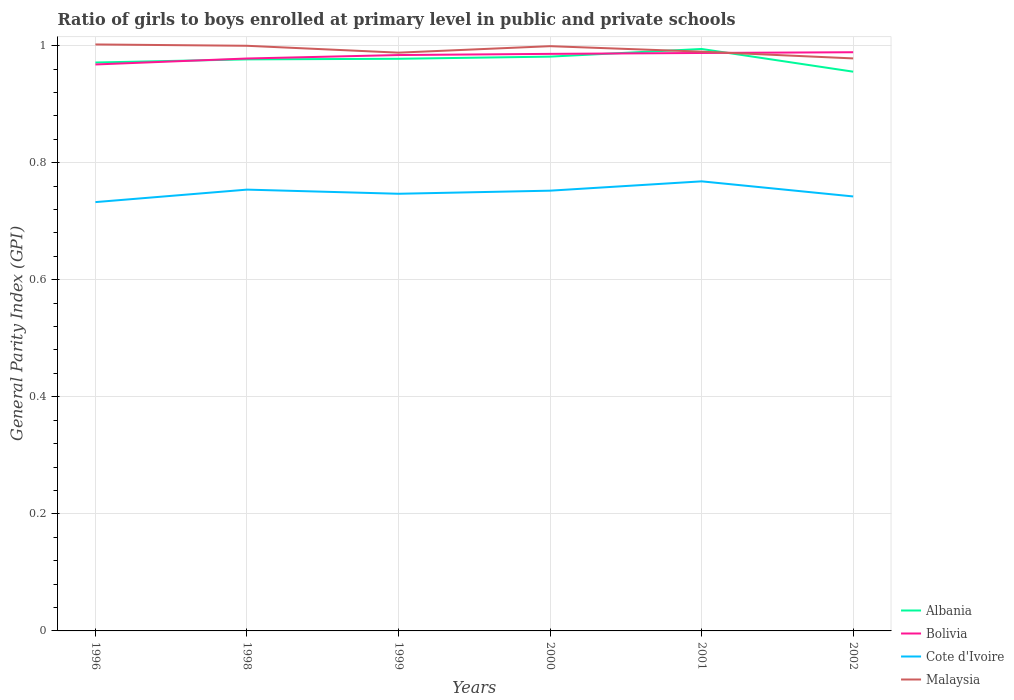How many different coloured lines are there?
Keep it short and to the point. 4. Does the line corresponding to Malaysia intersect with the line corresponding to Cote d'Ivoire?
Offer a terse response. No. Across all years, what is the maximum general parity index in Bolivia?
Offer a very short reply. 0.97. What is the total general parity index in Bolivia in the graph?
Your response must be concise. -0.02. What is the difference between the highest and the second highest general parity index in Malaysia?
Make the answer very short. 0.02. How many lines are there?
Your answer should be compact. 4. How many years are there in the graph?
Provide a short and direct response. 6. What is the title of the graph?
Offer a terse response. Ratio of girls to boys enrolled at primary level in public and private schools. What is the label or title of the Y-axis?
Your answer should be compact. General Parity Index (GPI). What is the General Parity Index (GPI) in Albania in 1996?
Your response must be concise. 0.97. What is the General Parity Index (GPI) in Bolivia in 1996?
Your answer should be very brief. 0.97. What is the General Parity Index (GPI) of Cote d'Ivoire in 1996?
Provide a succinct answer. 0.73. What is the General Parity Index (GPI) in Malaysia in 1996?
Offer a terse response. 1. What is the General Parity Index (GPI) of Albania in 1998?
Provide a succinct answer. 0.98. What is the General Parity Index (GPI) of Bolivia in 1998?
Your answer should be compact. 0.98. What is the General Parity Index (GPI) in Cote d'Ivoire in 1998?
Make the answer very short. 0.75. What is the General Parity Index (GPI) of Malaysia in 1998?
Offer a very short reply. 1. What is the General Parity Index (GPI) of Albania in 1999?
Provide a short and direct response. 0.98. What is the General Parity Index (GPI) of Bolivia in 1999?
Keep it short and to the point. 0.98. What is the General Parity Index (GPI) of Cote d'Ivoire in 1999?
Give a very brief answer. 0.75. What is the General Parity Index (GPI) in Malaysia in 1999?
Your answer should be compact. 0.99. What is the General Parity Index (GPI) of Albania in 2000?
Your answer should be compact. 0.98. What is the General Parity Index (GPI) of Bolivia in 2000?
Provide a succinct answer. 0.99. What is the General Parity Index (GPI) in Cote d'Ivoire in 2000?
Your answer should be very brief. 0.75. What is the General Parity Index (GPI) in Malaysia in 2000?
Your answer should be compact. 1. What is the General Parity Index (GPI) of Albania in 2001?
Ensure brevity in your answer.  0.99. What is the General Parity Index (GPI) in Bolivia in 2001?
Offer a very short reply. 0.99. What is the General Parity Index (GPI) in Cote d'Ivoire in 2001?
Ensure brevity in your answer.  0.77. What is the General Parity Index (GPI) of Malaysia in 2001?
Your answer should be compact. 0.99. What is the General Parity Index (GPI) in Albania in 2002?
Provide a succinct answer. 0.96. What is the General Parity Index (GPI) in Bolivia in 2002?
Provide a succinct answer. 0.99. What is the General Parity Index (GPI) of Cote d'Ivoire in 2002?
Keep it short and to the point. 0.74. What is the General Parity Index (GPI) in Malaysia in 2002?
Provide a short and direct response. 0.98. Across all years, what is the maximum General Parity Index (GPI) of Albania?
Give a very brief answer. 0.99. Across all years, what is the maximum General Parity Index (GPI) in Bolivia?
Offer a terse response. 0.99. Across all years, what is the maximum General Parity Index (GPI) in Cote d'Ivoire?
Make the answer very short. 0.77. Across all years, what is the maximum General Parity Index (GPI) of Malaysia?
Ensure brevity in your answer.  1. Across all years, what is the minimum General Parity Index (GPI) in Albania?
Your answer should be very brief. 0.96. Across all years, what is the minimum General Parity Index (GPI) in Bolivia?
Your answer should be very brief. 0.97. Across all years, what is the minimum General Parity Index (GPI) of Cote d'Ivoire?
Keep it short and to the point. 0.73. Across all years, what is the minimum General Parity Index (GPI) in Malaysia?
Provide a succinct answer. 0.98. What is the total General Parity Index (GPI) in Albania in the graph?
Your answer should be compact. 5.86. What is the total General Parity Index (GPI) of Bolivia in the graph?
Offer a terse response. 5.89. What is the total General Parity Index (GPI) in Cote d'Ivoire in the graph?
Ensure brevity in your answer.  4.5. What is the total General Parity Index (GPI) of Malaysia in the graph?
Provide a succinct answer. 5.96. What is the difference between the General Parity Index (GPI) in Albania in 1996 and that in 1998?
Offer a very short reply. -0.01. What is the difference between the General Parity Index (GPI) in Bolivia in 1996 and that in 1998?
Provide a succinct answer. -0.01. What is the difference between the General Parity Index (GPI) in Cote d'Ivoire in 1996 and that in 1998?
Provide a succinct answer. -0.02. What is the difference between the General Parity Index (GPI) in Malaysia in 1996 and that in 1998?
Offer a terse response. 0. What is the difference between the General Parity Index (GPI) in Albania in 1996 and that in 1999?
Offer a very short reply. -0.01. What is the difference between the General Parity Index (GPI) in Bolivia in 1996 and that in 1999?
Your answer should be compact. -0.02. What is the difference between the General Parity Index (GPI) in Cote d'Ivoire in 1996 and that in 1999?
Your answer should be very brief. -0.01. What is the difference between the General Parity Index (GPI) of Malaysia in 1996 and that in 1999?
Provide a succinct answer. 0.01. What is the difference between the General Parity Index (GPI) in Albania in 1996 and that in 2000?
Your response must be concise. -0.01. What is the difference between the General Parity Index (GPI) in Bolivia in 1996 and that in 2000?
Offer a terse response. -0.02. What is the difference between the General Parity Index (GPI) of Cote d'Ivoire in 1996 and that in 2000?
Your answer should be compact. -0.02. What is the difference between the General Parity Index (GPI) of Malaysia in 1996 and that in 2000?
Your answer should be very brief. 0. What is the difference between the General Parity Index (GPI) of Albania in 1996 and that in 2001?
Offer a very short reply. -0.02. What is the difference between the General Parity Index (GPI) of Bolivia in 1996 and that in 2001?
Keep it short and to the point. -0.02. What is the difference between the General Parity Index (GPI) in Cote d'Ivoire in 1996 and that in 2001?
Your response must be concise. -0.04. What is the difference between the General Parity Index (GPI) in Malaysia in 1996 and that in 2001?
Your answer should be compact. 0.01. What is the difference between the General Parity Index (GPI) in Albania in 1996 and that in 2002?
Your answer should be very brief. 0.02. What is the difference between the General Parity Index (GPI) of Bolivia in 1996 and that in 2002?
Your answer should be very brief. -0.02. What is the difference between the General Parity Index (GPI) of Cote d'Ivoire in 1996 and that in 2002?
Provide a short and direct response. -0.01. What is the difference between the General Parity Index (GPI) of Malaysia in 1996 and that in 2002?
Offer a terse response. 0.02. What is the difference between the General Parity Index (GPI) in Albania in 1998 and that in 1999?
Your answer should be compact. -0. What is the difference between the General Parity Index (GPI) of Bolivia in 1998 and that in 1999?
Ensure brevity in your answer.  -0.01. What is the difference between the General Parity Index (GPI) of Cote d'Ivoire in 1998 and that in 1999?
Offer a terse response. 0.01. What is the difference between the General Parity Index (GPI) of Malaysia in 1998 and that in 1999?
Your answer should be very brief. 0.01. What is the difference between the General Parity Index (GPI) of Albania in 1998 and that in 2000?
Make the answer very short. -0. What is the difference between the General Parity Index (GPI) of Bolivia in 1998 and that in 2000?
Give a very brief answer. -0.01. What is the difference between the General Parity Index (GPI) in Cote d'Ivoire in 1998 and that in 2000?
Provide a short and direct response. 0. What is the difference between the General Parity Index (GPI) of Malaysia in 1998 and that in 2000?
Provide a succinct answer. 0. What is the difference between the General Parity Index (GPI) in Albania in 1998 and that in 2001?
Your answer should be very brief. -0.02. What is the difference between the General Parity Index (GPI) in Bolivia in 1998 and that in 2001?
Give a very brief answer. -0.01. What is the difference between the General Parity Index (GPI) of Cote d'Ivoire in 1998 and that in 2001?
Give a very brief answer. -0.01. What is the difference between the General Parity Index (GPI) of Malaysia in 1998 and that in 2001?
Provide a short and direct response. 0.01. What is the difference between the General Parity Index (GPI) of Albania in 1998 and that in 2002?
Ensure brevity in your answer.  0.02. What is the difference between the General Parity Index (GPI) of Bolivia in 1998 and that in 2002?
Your response must be concise. -0.01. What is the difference between the General Parity Index (GPI) of Cote d'Ivoire in 1998 and that in 2002?
Provide a short and direct response. 0.01. What is the difference between the General Parity Index (GPI) of Malaysia in 1998 and that in 2002?
Your answer should be very brief. 0.02. What is the difference between the General Parity Index (GPI) in Albania in 1999 and that in 2000?
Ensure brevity in your answer.  -0. What is the difference between the General Parity Index (GPI) of Bolivia in 1999 and that in 2000?
Keep it short and to the point. -0. What is the difference between the General Parity Index (GPI) in Cote d'Ivoire in 1999 and that in 2000?
Make the answer very short. -0.01. What is the difference between the General Parity Index (GPI) of Malaysia in 1999 and that in 2000?
Keep it short and to the point. -0.01. What is the difference between the General Parity Index (GPI) in Albania in 1999 and that in 2001?
Give a very brief answer. -0.02. What is the difference between the General Parity Index (GPI) in Bolivia in 1999 and that in 2001?
Offer a terse response. -0. What is the difference between the General Parity Index (GPI) of Cote d'Ivoire in 1999 and that in 2001?
Make the answer very short. -0.02. What is the difference between the General Parity Index (GPI) of Malaysia in 1999 and that in 2001?
Your answer should be compact. -0. What is the difference between the General Parity Index (GPI) in Albania in 1999 and that in 2002?
Give a very brief answer. 0.02. What is the difference between the General Parity Index (GPI) in Bolivia in 1999 and that in 2002?
Offer a very short reply. -0. What is the difference between the General Parity Index (GPI) of Cote d'Ivoire in 1999 and that in 2002?
Provide a succinct answer. 0. What is the difference between the General Parity Index (GPI) of Malaysia in 1999 and that in 2002?
Keep it short and to the point. 0.01. What is the difference between the General Parity Index (GPI) in Albania in 2000 and that in 2001?
Ensure brevity in your answer.  -0.01. What is the difference between the General Parity Index (GPI) of Bolivia in 2000 and that in 2001?
Your response must be concise. -0. What is the difference between the General Parity Index (GPI) of Cote d'Ivoire in 2000 and that in 2001?
Ensure brevity in your answer.  -0.02. What is the difference between the General Parity Index (GPI) in Malaysia in 2000 and that in 2001?
Offer a very short reply. 0.01. What is the difference between the General Parity Index (GPI) in Albania in 2000 and that in 2002?
Make the answer very short. 0.03. What is the difference between the General Parity Index (GPI) of Bolivia in 2000 and that in 2002?
Your answer should be compact. -0. What is the difference between the General Parity Index (GPI) in Cote d'Ivoire in 2000 and that in 2002?
Your answer should be very brief. 0.01. What is the difference between the General Parity Index (GPI) in Malaysia in 2000 and that in 2002?
Provide a succinct answer. 0.02. What is the difference between the General Parity Index (GPI) in Albania in 2001 and that in 2002?
Give a very brief answer. 0.04. What is the difference between the General Parity Index (GPI) of Bolivia in 2001 and that in 2002?
Give a very brief answer. -0. What is the difference between the General Parity Index (GPI) of Cote d'Ivoire in 2001 and that in 2002?
Give a very brief answer. 0.03. What is the difference between the General Parity Index (GPI) in Malaysia in 2001 and that in 2002?
Offer a terse response. 0.01. What is the difference between the General Parity Index (GPI) of Albania in 1996 and the General Parity Index (GPI) of Bolivia in 1998?
Give a very brief answer. -0.01. What is the difference between the General Parity Index (GPI) of Albania in 1996 and the General Parity Index (GPI) of Cote d'Ivoire in 1998?
Make the answer very short. 0.22. What is the difference between the General Parity Index (GPI) in Albania in 1996 and the General Parity Index (GPI) in Malaysia in 1998?
Your response must be concise. -0.03. What is the difference between the General Parity Index (GPI) of Bolivia in 1996 and the General Parity Index (GPI) of Cote d'Ivoire in 1998?
Offer a terse response. 0.21. What is the difference between the General Parity Index (GPI) of Bolivia in 1996 and the General Parity Index (GPI) of Malaysia in 1998?
Offer a very short reply. -0.03. What is the difference between the General Parity Index (GPI) in Cote d'Ivoire in 1996 and the General Parity Index (GPI) in Malaysia in 1998?
Give a very brief answer. -0.27. What is the difference between the General Parity Index (GPI) of Albania in 1996 and the General Parity Index (GPI) of Bolivia in 1999?
Provide a short and direct response. -0.01. What is the difference between the General Parity Index (GPI) of Albania in 1996 and the General Parity Index (GPI) of Cote d'Ivoire in 1999?
Your response must be concise. 0.22. What is the difference between the General Parity Index (GPI) in Albania in 1996 and the General Parity Index (GPI) in Malaysia in 1999?
Make the answer very short. -0.02. What is the difference between the General Parity Index (GPI) in Bolivia in 1996 and the General Parity Index (GPI) in Cote d'Ivoire in 1999?
Offer a terse response. 0.22. What is the difference between the General Parity Index (GPI) in Bolivia in 1996 and the General Parity Index (GPI) in Malaysia in 1999?
Provide a short and direct response. -0.02. What is the difference between the General Parity Index (GPI) in Cote d'Ivoire in 1996 and the General Parity Index (GPI) in Malaysia in 1999?
Provide a short and direct response. -0.26. What is the difference between the General Parity Index (GPI) of Albania in 1996 and the General Parity Index (GPI) of Bolivia in 2000?
Your answer should be very brief. -0.01. What is the difference between the General Parity Index (GPI) in Albania in 1996 and the General Parity Index (GPI) in Cote d'Ivoire in 2000?
Give a very brief answer. 0.22. What is the difference between the General Parity Index (GPI) in Albania in 1996 and the General Parity Index (GPI) in Malaysia in 2000?
Give a very brief answer. -0.03. What is the difference between the General Parity Index (GPI) in Bolivia in 1996 and the General Parity Index (GPI) in Cote d'Ivoire in 2000?
Offer a terse response. 0.22. What is the difference between the General Parity Index (GPI) of Bolivia in 1996 and the General Parity Index (GPI) of Malaysia in 2000?
Give a very brief answer. -0.03. What is the difference between the General Parity Index (GPI) of Cote d'Ivoire in 1996 and the General Parity Index (GPI) of Malaysia in 2000?
Offer a very short reply. -0.27. What is the difference between the General Parity Index (GPI) of Albania in 1996 and the General Parity Index (GPI) of Bolivia in 2001?
Give a very brief answer. -0.02. What is the difference between the General Parity Index (GPI) of Albania in 1996 and the General Parity Index (GPI) of Cote d'Ivoire in 2001?
Your response must be concise. 0.2. What is the difference between the General Parity Index (GPI) of Albania in 1996 and the General Parity Index (GPI) of Malaysia in 2001?
Offer a terse response. -0.02. What is the difference between the General Parity Index (GPI) in Bolivia in 1996 and the General Parity Index (GPI) in Cote d'Ivoire in 2001?
Offer a very short reply. 0.2. What is the difference between the General Parity Index (GPI) in Bolivia in 1996 and the General Parity Index (GPI) in Malaysia in 2001?
Your response must be concise. -0.02. What is the difference between the General Parity Index (GPI) in Cote d'Ivoire in 1996 and the General Parity Index (GPI) in Malaysia in 2001?
Keep it short and to the point. -0.26. What is the difference between the General Parity Index (GPI) of Albania in 1996 and the General Parity Index (GPI) of Bolivia in 2002?
Make the answer very short. -0.02. What is the difference between the General Parity Index (GPI) of Albania in 1996 and the General Parity Index (GPI) of Cote d'Ivoire in 2002?
Your answer should be compact. 0.23. What is the difference between the General Parity Index (GPI) of Albania in 1996 and the General Parity Index (GPI) of Malaysia in 2002?
Provide a succinct answer. -0.01. What is the difference between the General Parity Index (GPI) in Bolivia in 1996 and the General Parity Index (GPI) in Cote d'Ivoire in 2002?
Make the answer very short. 0.23. What is the difference between the General Parity Index (GPI) of Bolivia in 1996 and the General Parity Index (GPI) of Malaysia in 2002?
Provide a short and direct response. -0.01. What is the difference between the General Parity Index (GPI) in Cote d'Ivoire in 1996 and the General Parity Index (GPI) in Malaysia in 2002?
Make the answer very short. -0.25. What is the difference between the General Parity Index (GPI) in Albania in 1998 and the General Parity Index (GPI) in Bolivia in 1999?
Provide a short and direct response. -0.01. What is the difference between the General Parity Index (GPI) in Albania in 1998 and the General Parity Index (GPI) in Cote d'Ivoire in 1999?
Give a very brief answer. 0.23. What is the difference between the General Parity Index (GPI) of Albania in 1998 and the General Parity Index (GPI) of Malaysia in 1999?
Give a very brief answer. -0.01. What is the difference between the General Parity Index (GPI) of Bolivia in 1998 and the General Parity Index (GPI) of Cote d'Ivoire in 1999?
Provide a short and direct response. 0.23. What is the difference between the General Parity Index (GPI) in Bolivia in 1998 and the General Parity Index (GPI) in Malaysia in 1999?
Your answer should be very brief. -0.01. What is the difference between the General Parity Index (GPI) in Cote d'Ivoire in 1998 and the General Parity Index (GPI) in Malaysia in 1999?
Offer a terse response. -0.23. What is the difference between the General Parity Index (GPI) of Albania in 1998 and the General Parity Index (GPI) of Bolivia in 2000?
Your response must be concise. -0.01. What is the difference between the General Parity Index (GPI) of Albania in 1998 and the General Parity Index (GPI) of Cote d'Ivoire in 2000?
Offer a terse response. 0.22. What is the difference between the General Parity Index (GPI) in Albania in 1998 and the General Parity Index (GPI) in Malaysia in 2000?
Give a very brief answer. -0.02. What is the difference between the General Parity Index (GPI) in Bolivia in 1998 and the General Parity Index (GPI) in Cote d'Ivoire in 2000?
Make the answer very short. 0.23. What is the difference between the General Parity Index (GPI) in Bolivia in 1998 and the General Parity Index (GPI) in Malaysia in 2000?
Ensure brevity in your answer.  -0.02. What is the difference between the General Parity Index (GPI) of Cote d'Ivoire in 1998 and the General Parity Index (GPI) of Malaysia in 2000?
Your answer should be compact. -0.25. What is the difference between the General Parity Index (GPI) in Albania in 1998 and the General Parity Index (GPI) in Bolivia in 2001?
Provide a short and direct response. -0.01. What is the difference between the General Parity Index (GPI) of Albania in 1998 and the General Parity Index (GPI) of Cote d'Ivoire in 2001?
Provide a succinct answer. 0.21. What is the difference between the General Parity Index (GPI) of Albania in 1998 and the General Parity Index (GPI) of Malaysia in 2001?
Offer a very short reply. -0.01. What is the difference between the General Parity Index (GPI) in Bolivia in 1998 and the General Parity Index (GPI) in Cote d'Ivoire in 2001?
Offer a very short reply. 0.21. What is the difference between the General Parity Index (GPI) of Bolivia in 1998 and the General Parity Index (GPI) of Malaysia in 2001?
Offer a very short reply. -0.01. What is the difference between the General Parity Index (GPI) in Cote d'Ivoire in 1998 and the General Parity Index (GPI) in Malaysia in 2001?
Your answer should be compact. -0.24. What is the difference between the General Parity Index (GPI) of Albania in 1998 and the General Parity Index (GPI) of Bolivia in 2002?
Provide a short and direct response. -0.01. What is the difference between the General Parity Index (GPI) in Albania in 1998 and the General Parity Index (GPI) in Cote d'Ivoire in 2002?
Make the answer very short. 0.23. What is the difference between the General Parity Index (GPI) of Albania in 1998 and the General Parity Index (GPI) of Malaysia in 2002?
Your response must be concise. -0. What is the difference between the General Parity Index (GPI) of Bolivia in 1998 and the General Parity Index (GPI) of Cote d'Ivoire in 2002?
Provide a succinct answer. 0.24. What is the difference between the General Parity Index (GPI) of Bolivia in 1998 and the General Parity Index (GPI) of Malaysia in 2002?
Your answer should be compact. -0. What is the difference between the General Parity Index (GPI) in Cote d'Ivoire in 1998 and the General Parity Index (GPI) in Malaysia in 2002?
Give a very brief answer. -0.22. What is the difference between the General Parity Index (GPI) in Albania in 1999 and the General Parity Index (GPI) in Bolivia in 2000?
Provide a succinct answer. -0.01. What is the difference between the General Parity Index (GPI) of Albania in 1999 and the General Parity Index (GPI) of Cote d'Ivoire in 2000?
Ensure brevity in your answer.  0.23. What is the difference between the General Parity Index (GPI) of Albania in 1999 and the General Parity Index (GPI) of Malaysia in 2000?
Provide a short and direct response. -0.02. What is the difference between the General Parity Index (GPI) in Bolivia in 1999 and the General Parity Index (GPI) in Cote d'Ivoire in 2000?
Make the answer very short. 0.23. What is the difference between the General Parity Index (GPI) of Bolivia in 1999 and the General Parity Index (GPI) of Malaysia in 2000?
Your response must be concise. -0.02. What is the difference between the General Parity Index (GPI) in Cote d'Ivoire in 1999 and the General Parity Index (GPI) in Malaysia in 2000?
Give a very brief answer. -0.25. What is the difference between the General Parity Index (GPI) of Albania in 1999 and the General Parity Index (GPI) of Bolivia in 2001?
Offer a very short reply. -0.01. What is the difference between the General Parity Index (GPI) in Albania in 1999 and the General Parity Index (GPI) in Cote d'Ivoire in 2001?
Give a very brief answer. 0.21. What is the difference between the General Parity Index (GPI) in Albania in 1999 and the General Parity Index (GPI) in Malaysia in 2001?
Your answer should be compact. -0.01. What is the difference between the General Parity Index (GPI) in Bolivia in 1999 and the General Parity Index (GPI) in Cote d'Ivoire in 2001?
Offer a very short reply. 0.22. What is the difference between the General Parity Index (GPI) of Bolivia in 1999 and the General Parity Index (GPI) of Malaysia in 2001?
Your answer should be very brief. -0.01. What is the difference between the General Parity Index (GPI) in Cote d'Ivoire in 1999 and the General Parity Index (GPI) in Malaysia in 2001?
Offer a terse response. -0.24. What is the difference between the General Parity Index (GPI) of Albania in 1999 and the General Parity Index (GPI) of Bolivia in 2002?
Offer a terse response. -0.01. What is the difference between the General Parity Index (GPI) of Albania in 1999 and the General Parity Index (GPI) of Cote d'Ivoire in 2002?
Keep it short and to the point. 0.24. What is the difference between the General Parity Index (GPI) in Albania in 1999 and the General Parity Index (GPI) in Malaysia in 2002?
Your answer should be compact. -0. What is the difference between the General Parity Index (GPI) of Bolivia in 1999 and the General Parity Index (GPI) of Cote d'Ivoire in 2002?
Keep it short and to the point. 0.24. What is the difference between the General Parity Index (GPI) in Bolivia in 1999 and the General Parity Index (GPI) in Malaysia in 2002?
Give a very brief answer. 0.01. What is the difference between the General Parity Index (GPI) of Cote d'Ivoire in 1999 and the General Parity Index (GPI) of Malaysia in 2002?
Keep it short and to the point. -0.23. What is the difference between the General Parity Index (GPI) of Albania in 2000 and the General Parity Index (GPI) of Bolivia in 2001?
Make the answer very short. -0.01. What is the difference between the General Parity Index (GPI) of Albania in 2000 and the General Parity Index (GPI) of Cote d'Ivoire in 2001?
Offer a terse response. 0.21. What is the difference between the General Parity Index (GPI) in Albania in 2000 and the General Parity Index (GPI) in Malaysia in 2001?
Keep it short and to the point. -0.01. What is the difference between the General Parity Index (GPI) of Bolivia in 2000 and the General Parity Index (GPI) of Cote d'Ivoire in 2001?
Make the answer very short. 0.22. What is the difference between the General Parity Index (GPI) in Bolivia in 2000 and the General Parity Index (GPI) in Malaysia in 2001?
Offer a very short reply. -0. What is the difference between the General Parity Index (GPI) in Cote d'Ivoire in 2000 and the General Parity Index (GPI) in Malaysia in 2001?
Offer a very short reply. -0.24. What is the difference between the General Parity Index (GPI) in Albania in 2000 and the General Parity Index (GPI) in Bolivia in 2002?
Make the answer very short. -0.01. What is the difference between the General Parity Index (GPI) of Albania in 2000 and the General Parity Index (GPI) of Cote d'Ivoire in 2002?
Your answer should be very brief. 0.24. What is the difference between the General Parity Index (GPI) in Albania in 2000 and the General Parity Index (GPI) in Malaysia in 2002?
Keep it short and to the point. 0. What is the difference between the General Parity Index (GPI) in Bolivia in 2000 and the General Parity Index (GPI) in Cote d'Ivoire in 2002?
Offer a very short reply. 0.24. What is the difference between the General Parity Index (GPI) in Bolivia in 2000 and the General Parity Index (GPI) in Malaysia in 2002?
Your answer should be very brief. 0.01. What is the difference between the General Parity Index (GPI) of Cote d'Ivoire in 2000 and the General Parity Index (GPI) of Malaysia in 2002?
Keep it short and to the point. -0.23. What is the difference between the General Parity Index (GPI) of Albania in 2001 and the General Parity Index (GPI) of Bolivia in 2002?
Your answer should be compact. 0.01. What is the difference between the General Parity Index (GPI) in Albania in 2001 and the General Parity Index (GPI) in Cote d'Ivoire in 2002?
Make the answer very short. 0.25. What is the difference between the General Parity Index (GPI) of Albania in 2001 and the General Parity Index (GPI) of Malaysia in 2002?
Ensure brevity in your answer.  0.02. What is the difference between the General Parity Index (GPI) of Bolivia in 2001 and the General Parity Index (GPI) of Cote d'Ivoire in 2002?
Your response must be concise. 0.25. What is the difference between the General Parity Index (GPI) of Bolivia in 2001 and the General Parity Index (GPI) of Malaysia in 2002?
Your answer should be compact. 0.01. What is the difference between the General Parity Index (GPI) of Cote d'Ivoire in 2001 and the General Parity Index (GPI) of Malaysia in 2002?
Provide a short and direct response. -0.21. What is the average General Parity Index (GPI) of Albania per year?
Ensure brevity in your answer.  0.98. What is the average General Parity Index (GPI) of Cote d'Ivoire per year?
Offer a terse response. 0.75. In the year 1996, what is the difference between the General Parity Index (GPI) in Albania and General Parity Index (GPI) in Bolivia?
Make the answer very short. 0. In the year 1996, what is the difference between the General Parity Index (GPI) of Albania and General Parity Index (GPI) of Cote d'Ivoire?
Offer a terse response. 0.24. In the year 1996, what is the difference between the General Parity Index (GPI) of Albania and General Parity Index (GPI) of Malaysia?
Provide a succinct answer. -0.03. In the year 1996, what is the difference between the General Parity Index (GPI) of Bolivia and General Parity Index (GPI) of Cote d'Ivoire?
Your response must be concise. 0.24. In the year 1996, what is the difference between the General Parity Index (GPI) in Bolivia and General Parity Index (GPI) in Malaysia?
Provide a short and direct response. -0.03. In the year 1996, what is the difference between the General Parity Index (GPI) in Cote d'Ivoire and General Parity Index (GPI) in Malaysia?
Keep it short and to the point. -0.27. In the year 1998, what is the difference between the General Parity Index (GPI) of Albania and General Parity Index (GPI) of Bolivia?
Your answer should be very brief. -0. In the year 1998, what is the difference between the General Parity Index (GPI) in Albania and General Parity Index (GPI) in Cote d'Ivoire?
Your response must be concise. 0.22. In the year 1998, what is the difference between the General Parity Index (GPI) of Albania and General Parity Index (GPI) of Malaysia?
Ensure brevity in your answer.  -0.02. In the year 1998, what is the difference between the General Parity Index (GPI) of Bolivia and General Parity Index (GPI) of Cote d'Ivoire?
Make the answer very short. 0.22. In the year 1998, what is the difference between the General Parity Index (GPI) of Bolivia and General Parity Index (GPI) of Malaysia?
Make the answer very short. -0.02. In the year 1998, what is the difference between the General Parity Index (GPI) of Cote d'Ivoire and General Parity Index (GPI) of Malaysia?
Provide a succinct answer. -0.25. In the year 1999, what is the difference between the General Parity Index (GPI) in Albania and General Parity Index (GPI) in Bolivia?
Give a very brief answer. -0.01. In the year 1999, what is the difference between the General Parity Index (GPI) in Albania and General Parity Index (GPI) in Cote d'Ivoire?
Ensure brevity in your answer.  0.23. In the year 1999, what is the difference between the General Parity Index (GPI) of Albania and General Parity Index (GPI) of Malaysia?
Your answer should be compact. -0.01. In the year 1999, what is the difference between the General Parity Index (GPI) in Bolivia and General Parity Index (GPI) in Cote d'Ivoire?
Your response must be concise. 0.24. In the year 1999, what is the difference between the General Parity Index (GPI) of Bolivia and General Parity Index (GPI) of Malaysia?
Give a very brief answer. -0. In the year 1999, what is the difference between the General Parity Index (GPI) of Cote d'Ivoire and General Parity Index (GPI) of Malaysia?
Your response must be concise. -0.24. In the year 2000, what is the difference between the General Parity Index (GPI) of Albania and General Parity Index (GPI) of Bolivia?
Your answer should be compact. -0. In the year 2000, what is the difference between the General Parity Index (GPI) of Albania and General Parity Index (GPI) of Cote d'Ivoire?
Make the answer very short. 0.23. In the year 2000, what is the difference between the General Parity Index (GPI) of Albania and General Parity Index (GPI) of Malaysia?
Provide a succinct answer. -0.02. In the year 2000, what is the difference between the General Parity Index (GPI) of Bolivia and General Parity Index (GPI) of Cote d'Ivoire?
Your response must be concise. 0.23. In the year 2000, what is the difference between the General Parity Index (GPI) of Bolivia and General Parity Index (GPI) of Malaysia?
Make the answer very short. -0.01. In the year 2000, what is the difference between the General Parity Index (GPI) in Cote d'Ivoire and General Parity Index (GPI) in Malaysia?
Offer a very short reply. -0.25. In the year 2001, what is the difference between the General Parity Index (GPI) of Albania and General Parity Index (GPI) of Bolivia?
Give a very brief answer. 0.01. In the year 2001, what is the difference between the General Parity Index (GPI) in Albania and General Parity Index (GPI) in Cote d'Ivoire?
Offer a terse response. 0.23. In the year 2001, what is the difference between the General Parity Index (GPI) of Albania and General Parity Index (GPI) of Malaysia?
Ensure brevity in your answer.  0. In the year 2001, what is the difference between the General Parity Index (GPI) of Bolivia and General Parity Index (GPI) of Cote d'Ivoire?
Make the answer very short. 0.22. In the year 2001, what is the difference between the General Parity Index (GPI) of Bolivia and General Parity Index (GPI) of Malaysia?
Give a very brief answer. -0. In the year 2001, what is the difference between the General Parity Index (GPI) in Cote d'Ivoire and General Parity Index (GPI) in Malaysia?
Your answer should be very brief. -0.22. In the year 2002, what is the difference between the General Parity Index (GPI) in Albania and General Parity Index (GPI) in Bolivia?
Keep it short and to the point. -0.03. In the year 2002, what is the difference between the General Parity Index (GPI) of Albania and General Parity Index (GPI) of Cote d'Ivoire?
Your answer should be very brief. 0.21. In the year 2002, what is the difference between the General Parity Index (GPI) in Albania and General Parity Index (GPI) in Malaysia?
Offer a very short reply. -0.02. In the year 2002, what is the difference between the General Parity Index (GPI) of Bolivia and General Parity Index (GPI) of Cote d'Ivoire?
Your answer should be compact. 0.25. In the year 2002, what is the difference between the General Parity Index (GPI) in Bolivia and General Parity Index (GPI) in Malaysia?
Provide a succinct answer. 0.01. In the year 2002, what is the difference between the General Parity Index (GPI) of Cote d'Ivoire and General Parity Index (GPI) of Malaysia?
Offer a very short reply. -0.24. What is the ratio of the General Parity Index (GPI) in Bolivia in 1996 to that in 1998?
Give a very brief answer. 0.99. What is the ratio of the General Parity Index (GPI) of Cote d'Ivoire in 1996 to that in 1998?
Your answer should be very brief. 0.97. What is the ratio of the General Parity Index (GPI) of Albania in 1996 to that in 1999?
Keep it short and to the point. 0.99. What is the ratio of the General Parity Index (GPI) in Bolivia in 1996 to that in 1999?
Make the answer very short. 0.98. What is the ratio of the General Parity Index (GPI) of Cote d'Ivoire in 1996 to that in 1999?
Offer a very short reply. 0.98. What is the ratio of the General Parity Index (GPI) of Malaysia in 1996 to that in 1999?
Your answer should be compact. 1.01. What is the ratio of the General Parity Index (GPI) in Bolivia in 1996 to that in 2000?
Keep it short and to the point. 0.98. What is the ratio of the General Parity Index (GPI) in Albania in 1996 to that in 2001?
Provide a succinct answer. 0.98. What is the ratio of the General Parity Index (GPI) in Bolivia in 1996 to that in 2001?
Keep it short and to the point. 0.98. What is the ratio of the General Parity Index (GPI) of Cote d'Ivoire in 1996 to that in 2001?
Offer a very short reply. 0.95. What is the ratio of the General Parity Index (GPI) of Malaysia in 1996 to that in 2001?
Ensure brevity in your answer.  1.01. What is the ratio of the General Parity Index (GPI) in Albania in 1996 to that in 2002?
Offer a very short reply. 1.02. What is the ratio of the General Parity Index (GPI) of Bolivia in 1996 to that in 2002?
Make the answer very short. 0.98. What is the ratio of the General Parity Index (GPI) of Malaysia in 1996 to that in 2002?
Give a very brief answer. 1.02. What is the ratio of the General Parity Index (GPI) of Albania in 1998 to that in 1999?
Keep it short and to the point. 1. What is the ratio of the General Parity Index (GPI) in Cote d'Ivoire in 1998 to that in 1999?
Make the answer very short. 1.01. What is the ratio of the General Parity Index (GPI) in Malaysia in 1998 to that in 1999?
Ensure brevity in your answer.  1.01. What is the ratio of the General Parity Index (GPI) in Albania in 1998 to that in 2001?
Ensure brevity in your answer.  0.98. What is the ratio of the General Parity Index (GPI) of Bolivia in 1998 to that in 2001?
Your answer should be very brief. 0.99. What is the ratio of the General Parity Index (GPI) in Cote d'Ivoire in 1998 to that in 2001?
Provide a short and direct response. 0.98. What is the ratio of the General Parity Index (GPI) in Malaysia in 1998 to that in 2001?
Your response must be concise. 1.01. What is the ratio of the General Parity Index (GPI) of Albania in 1998 to that in 2002?
Make the answer very short. 1.02. What is the ratio of the General Parity Index (GPI) in Cote d'Ivoire in 1998 to that in 2002?
Offer a very short reply. 1.02. What is the ratio of the General Parity Index (GPI) in Malaysia in 1998 to that in 2002?
Provide a succinct answer. 1.02. What is the ratio of the General Parity Index (GPI) in Albania in 1999 to that in 2000?
Offer a very short reply. 1. What is the ratio of the General Parity Index (GPI) of Bolivia in 1999 to that in 2000?
Your response must be concise. 1. What is the ratio of the General Parity Index (GPI) of Malaysia in 1999 to that in 2000?
Your answer should be compact. 0.99. What is the ratio of the General Parity Index (GPI) in Albania in 1999 to that in 2001?
Make the answer very short. 0.98. What is the ratio of the General Parity Index (GPI) in Bolivia in 1999 to that in 2001?
Provide a short and direct response. 1. What is the ratio of the General Parity Index (GPI) of Cote d'Ivoire in 1999 to that in 2001?
Your answer should be compact. 0.97. What is the ratio of the General Parity Index (GPI) in Albania in 1999 to that in 2002?
Give a very brief answer. 1.02. What is the ratio of the General Parity Index (GPI) of Bolivia in 1999 to that in 2002?
Your answer should be compact. 1. What is the ratio of the General Parity Index (GPI) in Albania in 2000 to that in 2001?
Your answer should be very brief. 0.99. What is the ratio of the General Parity Index (GPI) of Cote d'Ivoire in 2000 to that in 2001?
Your answer should be compact. 0.98. What is the ratio of the General Parity Index (GPI) of Malaysia in 2000 to that in 2001?
Your answer should be very brief. 1.01. What is the ratio of the General Parity Index (GPI) of Albania in 2000 to that in 2002?
Ensure brevity in your answer.  1.03. What is the ratio of the General Parity Index (GPI) in Bolivia in 2000 to that in 2002?
Keep it short and to the point. 1. What is the ratio of the General Parity Index (GPI) of Cote d'Ivoire in 2000 to that in 2002?
Make the answer very short. 1.01. What is the ratio of the General Parity Index (GPI) of Malaysia in 2000 to that in 2002?
Offer a very short reply. 1.02. What is the ratio of the General Parity Index (GPI) in Albania in 2001 to that in 2002?
Give a very brief answer. 1.04. What is the ratio of the General Parity Index (GPI) in Bolivia in 2001 to that in 2002?
Make the answer very short. 1. What is the ratio of the General Parity Index (GPI) in Cote d'Ivoire in 2001 to that in 2002?
Provide a succinct answer. 1.03. What is the ratio of the General Parity Index (GPI) of Malaysia in 2001 to that in 2002?
Ensure brevity in your answer.  1.01. What is the difference between the highest and the second highest General Parity Index (GPI) in Albania?
Keep it short and to the point. 0.01. What is the difference between the highest and the second highest General Parity Index (GPI) in Bolivia?
Provide a short and direct response. 0. What is the difference between the highest and the second highest General Parity Index (GPI) in Cote d'Ivoire?
Keep it short and to the point. 0.01. What is the difference between the highest and the second highest General Parity Index (GPI) in Malaysia?
Keep it short and to the point. 0. What is the difference between the highest and the lowest General Parity Index (GPI) in Albania?
Give a very brief answer. 0.04. What is the difference between the highest and the lowest General Parity Index (GPI) of Bolivia?
Provide a short and direct response. 0.02. What is the difference between the highest and the lowest General Parity Index (GPI) in Cote d'Ivoire?
Give a very brief answer. 0.04. What is the difference between the highest and the lowest General Parity Index (GPI) of Malaysia?
Your answer should be compact. 0.02. 